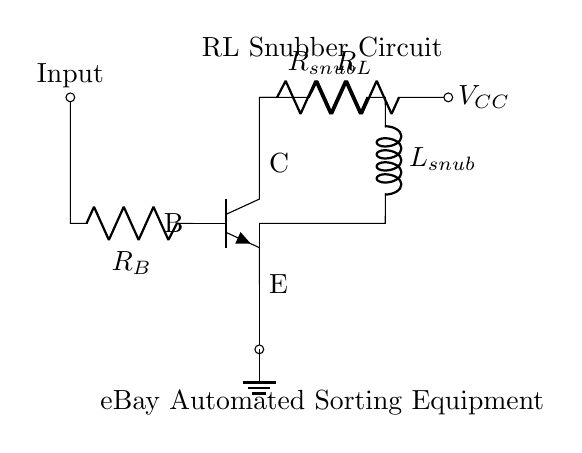What is the type of the transistor used in this circuit? The circuit shows an npn transistor, indicated by the symbol and the labeled connections (B for base, C for collector, and E for emitter).
Answer: npn What are the two main components of the snubber circuit? The snubber circuit consists of a resistor (labeled R_snub) and an inductor (labeled L_snub), both connected in series.
Answer: Resistor and Inductor What is the input connection's relationship with the transistor's base? The input connection is connected directly to the base (B) of the transistor, providing the control signal needed for operation.
Answer: Direct connection Which component is connected to the collector of the transistor? The resistor (labeled R_L) is connected to the collector (C) of the transistor, influencing the current flow from the collector to the power supply.
Answer: R_L How does the snubber circuit affect switching transients? The snubber circuit absorbs switching transients, reducing voltage spikes that can damage the transistor and improve reliability.
Answer: Absorbs transients What happens to the current when the snubber circuit is activated? When activated, the snubber circuit limits the rate of current change (di/dt), protecting the transistor from high-frequency fluctuations.
Answer: Limits di/dt 